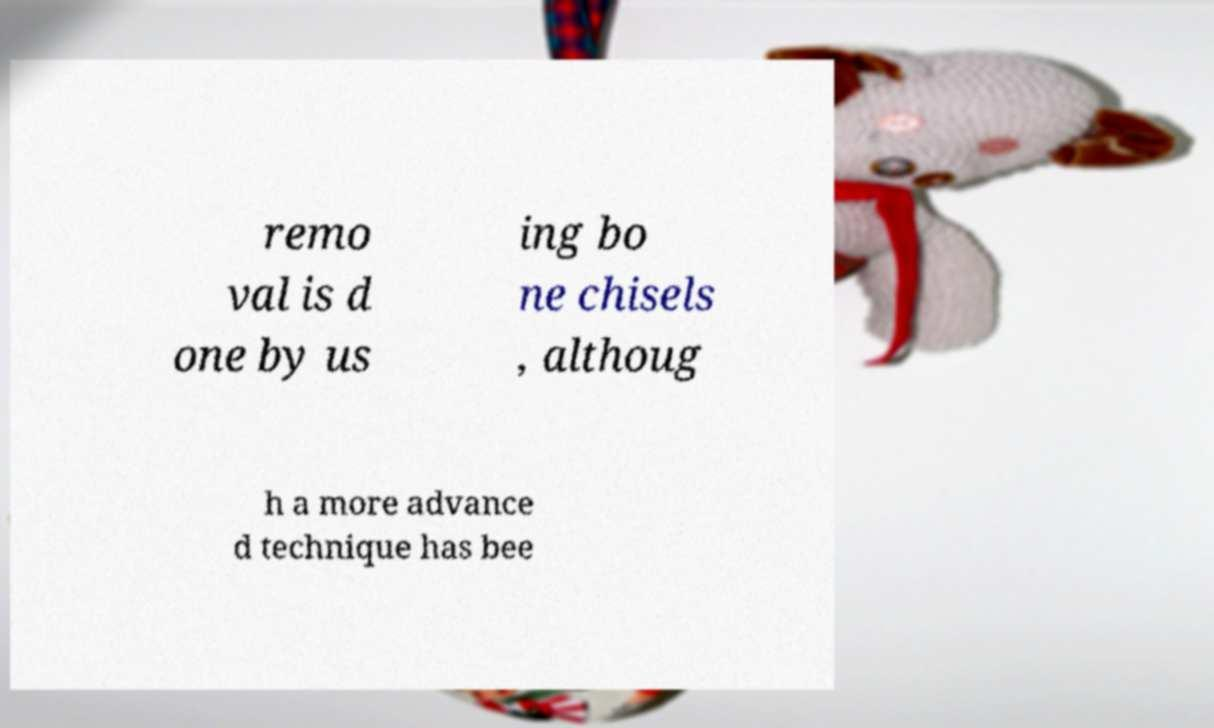What messages or text are displayed in this image? I need them in a readable, typed format. remo val is d one by us ing bo ne chisels , althoug h a more advance d technique has bee 